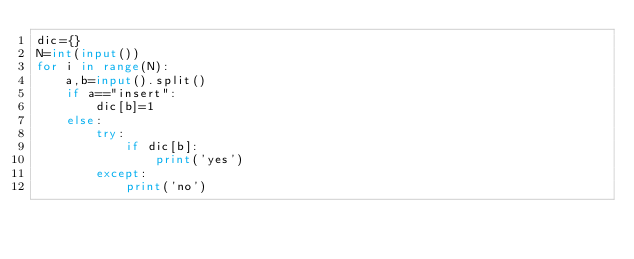<code> <loc_0><loc_0><loc_500><loc_500><_Python_>dic={}
N=int(input())
for i in range(N):
    a,b=input().split()
    if a=="insert":
        dic[b]=1
    else:
        try:
            if dic[b]:
                print('yes')
        except:
            print('no')
</code> 